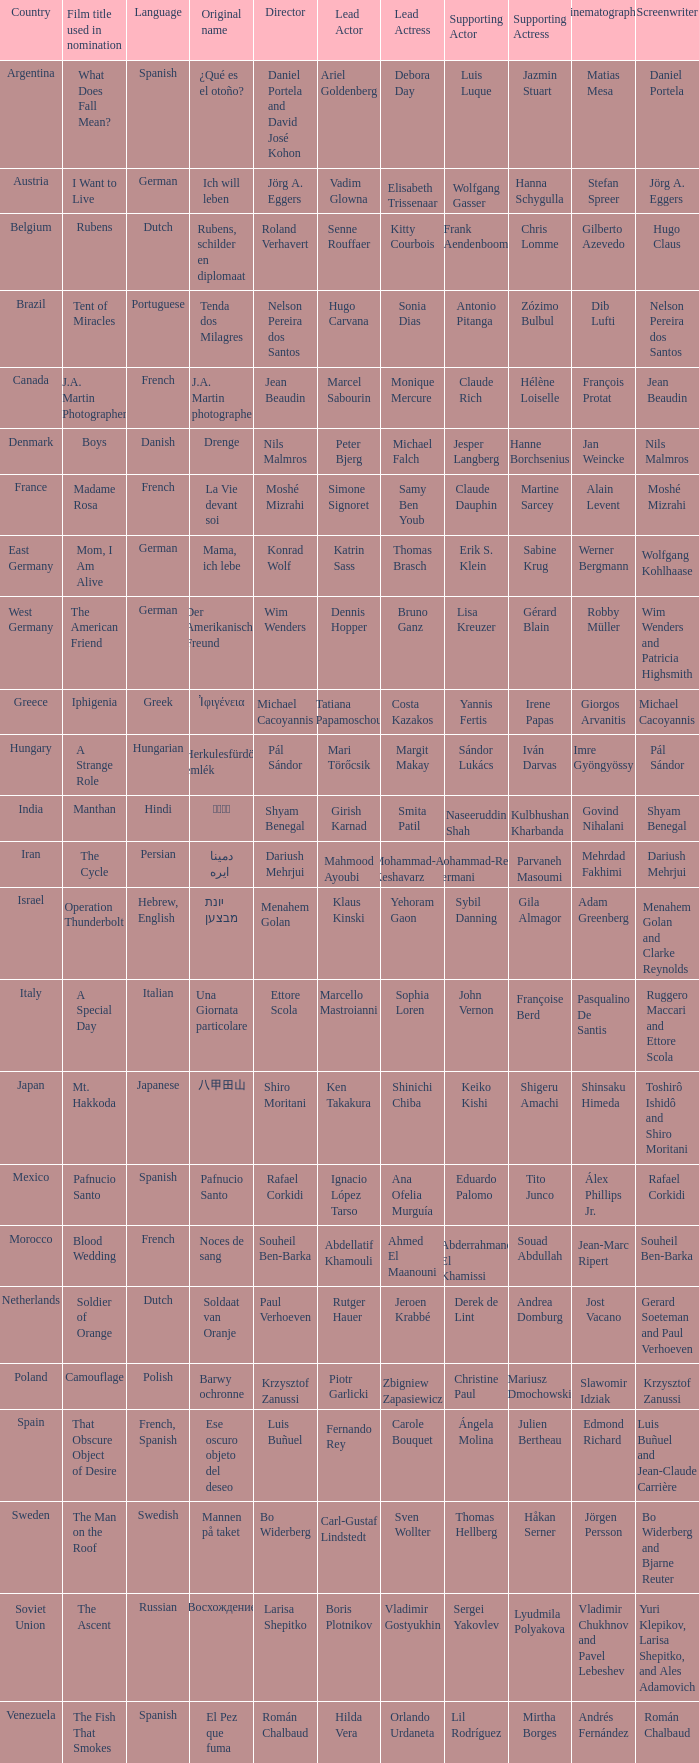Which director is from Italy? Ettore Scola. 